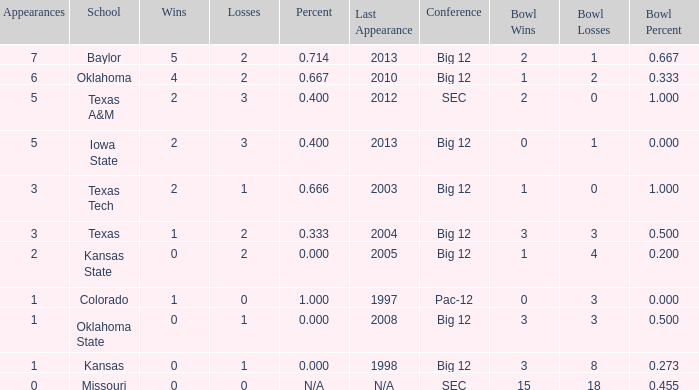How many schools had the win loss ratio of 0.667?  1.0. 